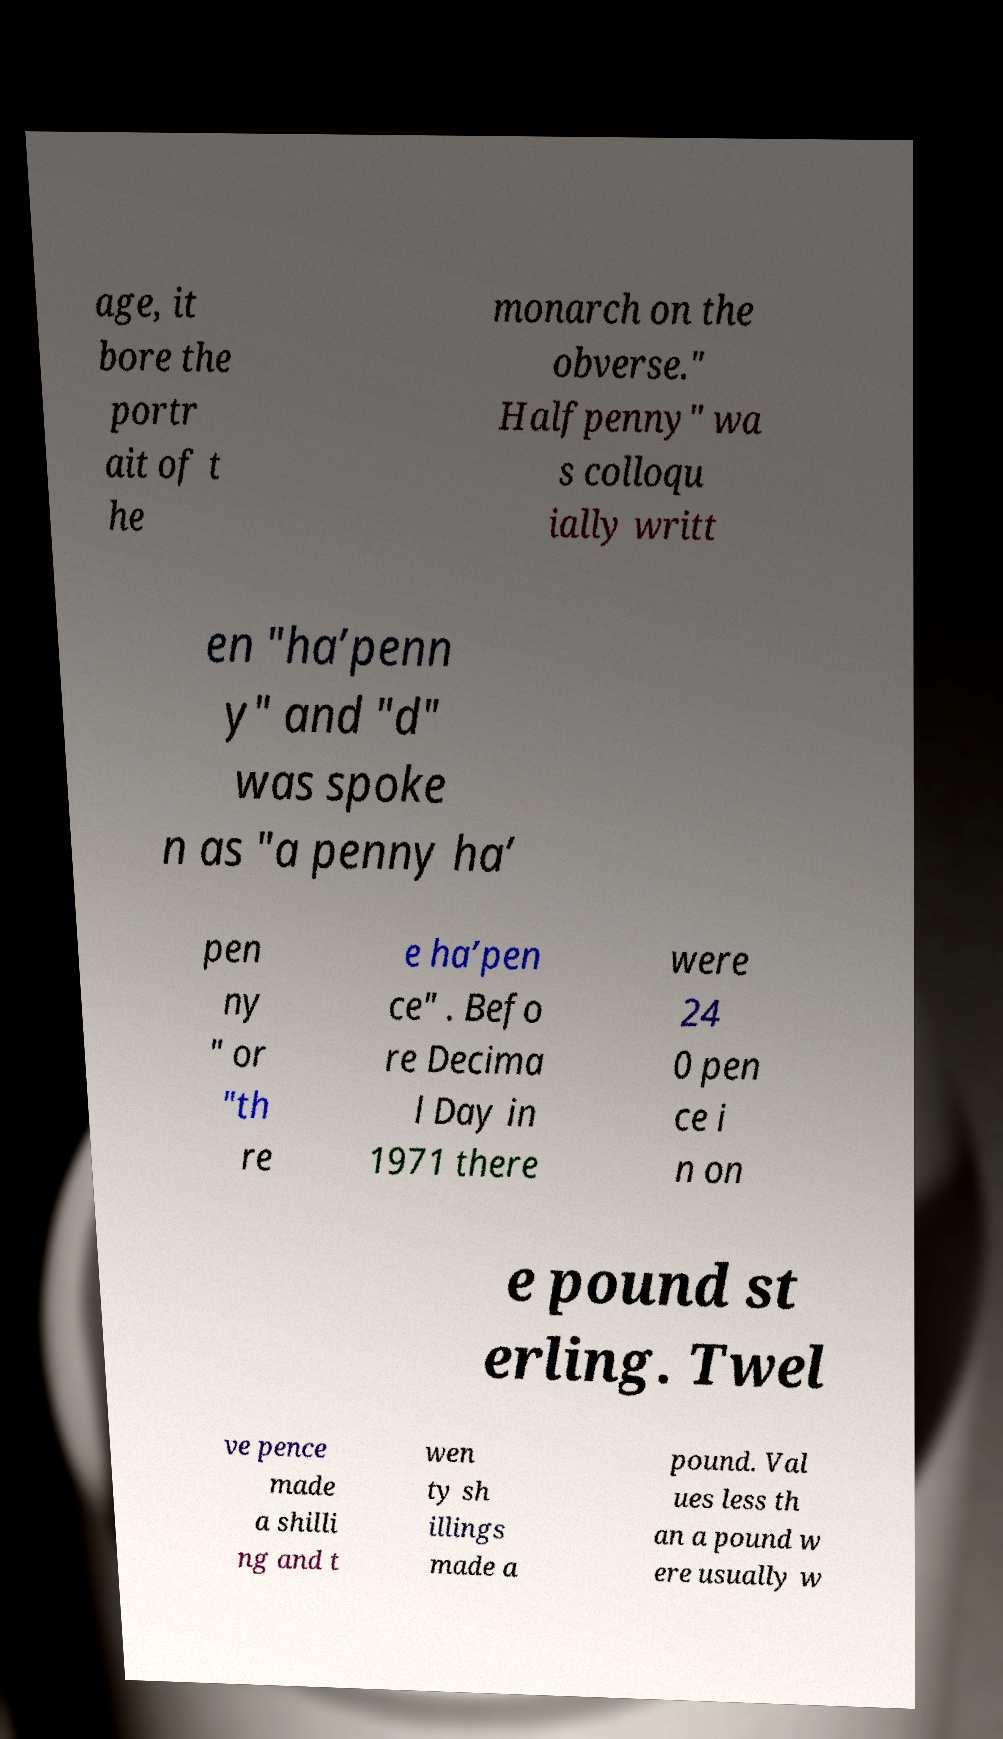What messages or text are displayed in this image? I need them in a readable, typed format. age, it bore the portr ait of t he monarch on the obverse." Halfpenny" wa s colloqu ially writt en "ha’penn y" and "d" was spoke n as "a penny ha’ pen ny " or "th re e ha’pen ce" . Befo re Decima l Day in 1971 there were 24 0 pen ce i n on e pound st erling. Twel ve pence made a shilli ng and t wen ty sh illings made a pound. Val ues less th an a pound w ere usually w 